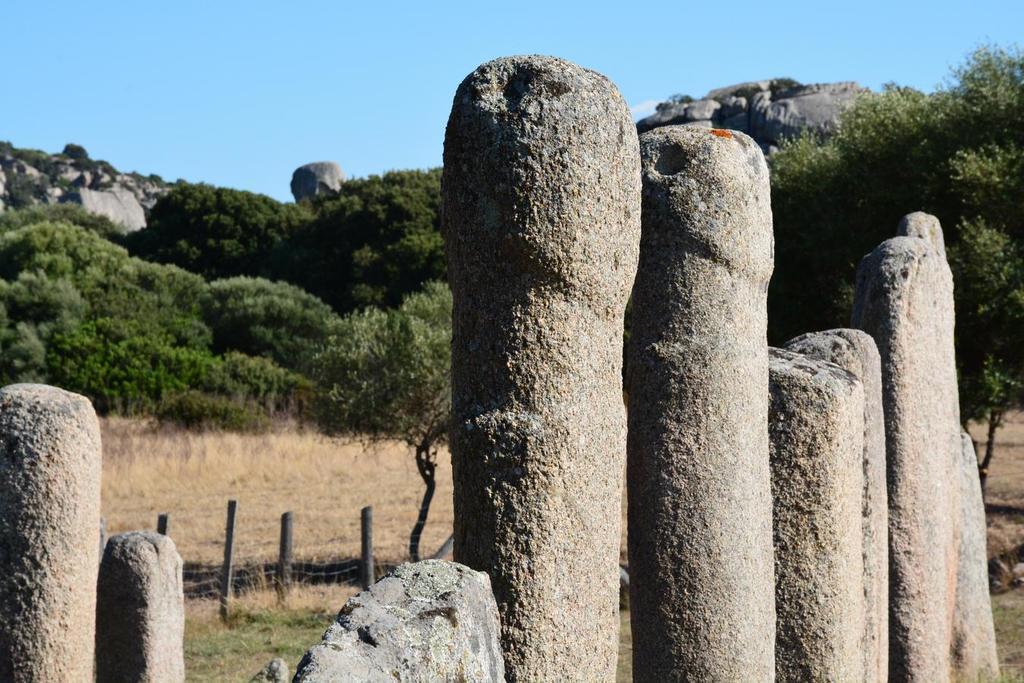Could you give a brief overview of what you see in this image? In this image in the foreground there are some poles and in the background there are some trees, fence and grass and also some rocks. On the top of the image there is sky. 